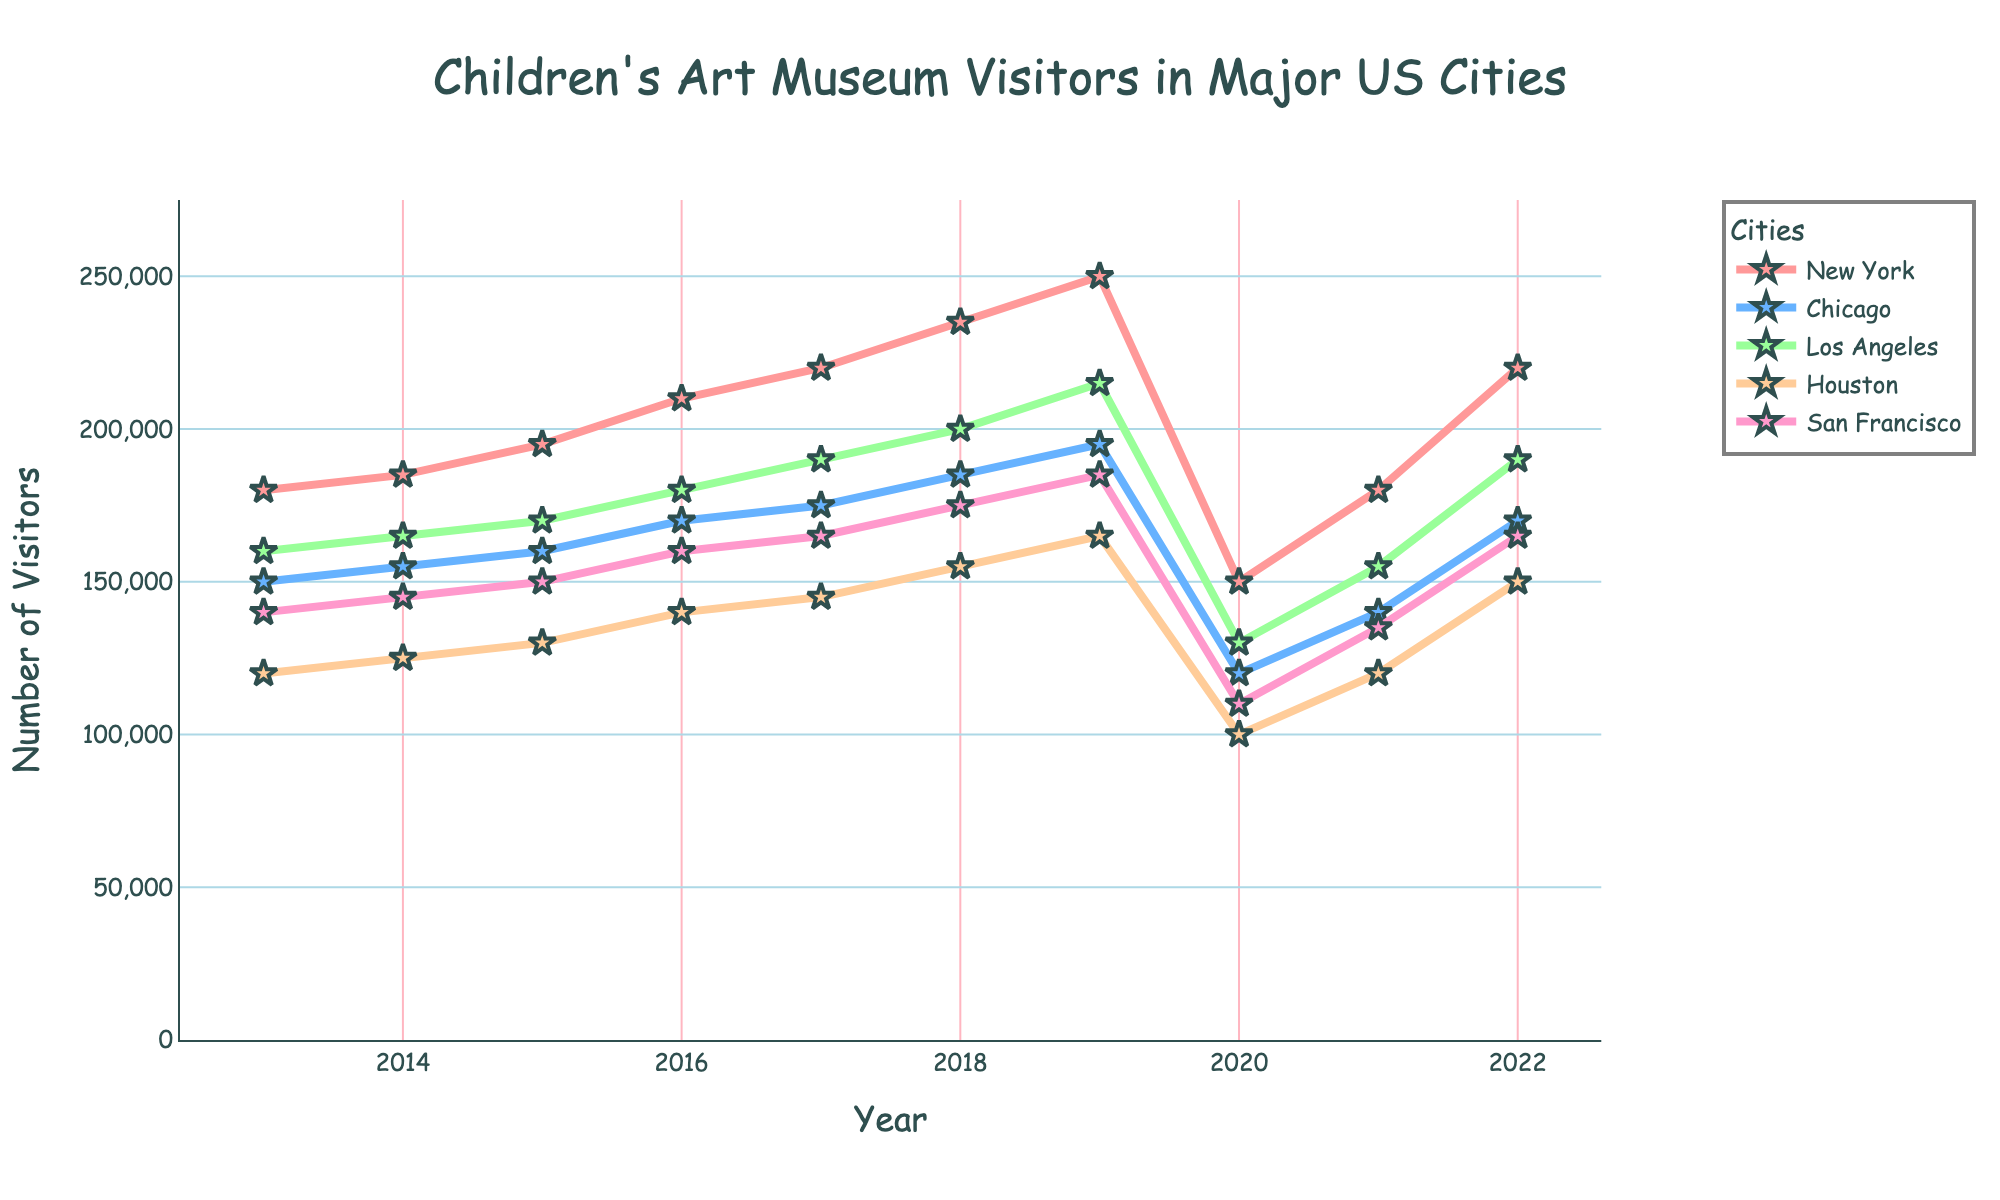Which city had the most visitors in 2022? Look at the line markers in 2022 and identify the city with the highest value.
Answer: New York How many visitors did Chicago have in 2019? Locate the line for Chicago and find its value in 2019.
Answer: 195,000 Which city had the least visitors in 2020? Find the city line that touches the lowest point in 2020.
Answer: Houston Between New York and Los Angeles, which had more visitors in 2017, and by how much? Compare the values for New York and Los Angeles in 2017, then subtract to find the difference.
Answer: New York by 30,000 What was the average number of visitors in San Francisco over the decade? Sum the annual visitors to San Francisco, then divide by the number of years (10). (140,000 + 145,000 + 150,000 + 160,000 + 165,000 + 175,000 + 185,000 + 110,000 + 135,000 + 165,000) / 10 = 153,000
Answer: 153,000 Which city had the steepest decline in visitors from 2019 to 2020? Compare the drops in visitor numbers in all cities from 2019 to 2020 and identify the greatest decline.
Answer: New York How does the number of visitors in Houston in 2021 compare to 2014? Look at the visitor numbers for Houston in 2021 and 2014 and subtract to find the difference.
Answer: Higher by 25,000 What is the total number of visitors for all cities combined in 2016? Sum the visitor numbers for each city in 2016. (210,000 + 170,000 + 180,000 + 140,000 + 160,000) = 860,000
Answer: 860,000 Which city showed the most consistent increase in the number of visitors from 2013 to 2019? Compare the slope or trend of each city's line from 2013 to 2019 to find the most consistently upward.
Answer: New York 